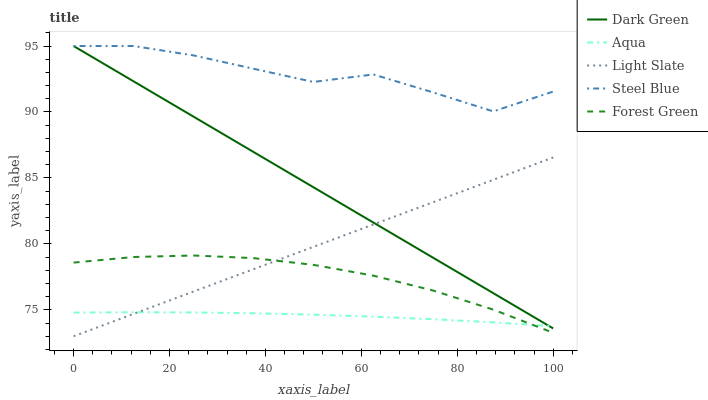Does Aqua have the minimum area under the curve?
Answer yes or no. Yes. Does Steel Blue have the maximum area under the curve?
Answer yes or no. Yes. Does Forest Green have the minimum area under the curve?
Answer yes or no. No. Does Forest Green have the maximum area under the curve?
Answer yes or no. No. Is Dark Green the smoothest?
Answer yes or no. Yes. Is Steel Blue the roughest?
Answer yes or no. Yes. Is Forest Green the smoothest?
Answer yes or no. No. Is Forest Green the roughest?
Answer yes or no. No. Does Light Slate have the lowest value?
Answer yes or no. Yes. Does Forest Green have the lowest value?
Answer yes or no. No. Does Dark Green have the highest value?
Answer yes or no. Yes. Does Forest Green have the highest value?
Answer yes or no. No. Is Forest Green less than Steel Blue?
Answer yes or no. Yes. Is Dark Green greater than Forest Green?
Answer yes or no. Yes. Does Dark Green intersect Steel Blue?
Answer yes or no. Yes. Is Dark Green less than Steel Blue?
Answer yes or no. No. Is Dark Green greater than Steel Blue?
Answer yes or no. No. Does Forest Green intersect Steel Blue?
Answer yes or no. No. 